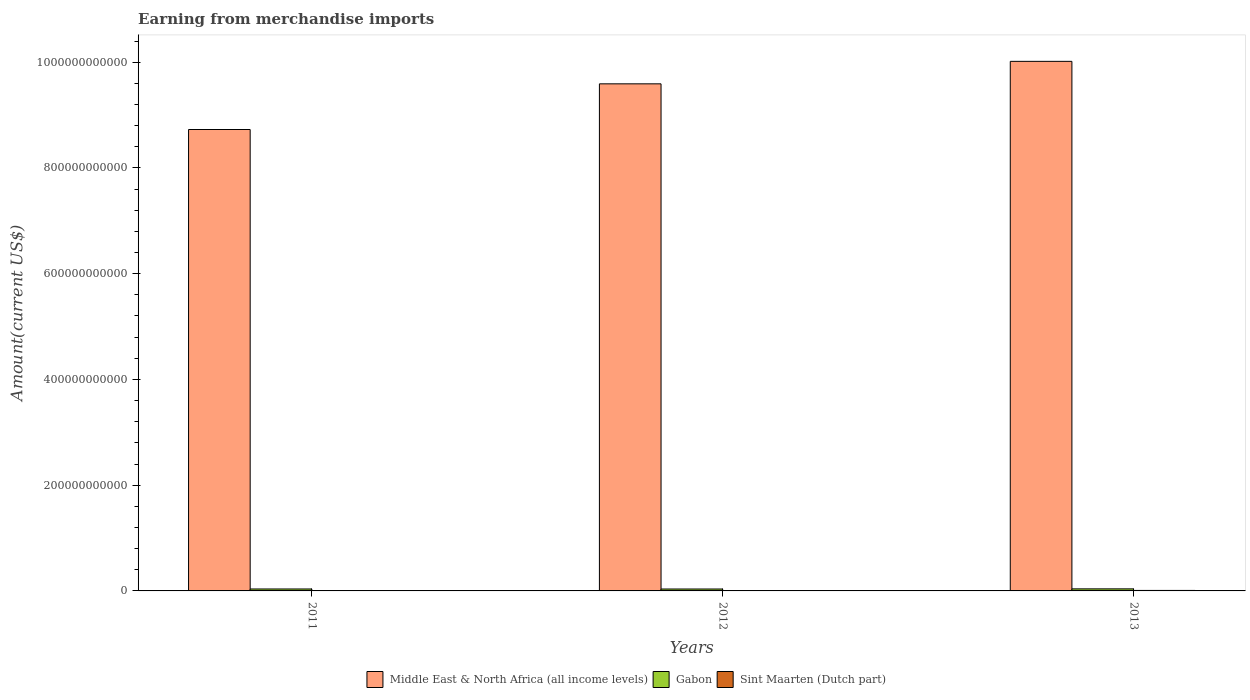How many bars are there on the 1st tick from the left?
Keep it short and to the point. 3. What is the label of the 2nd group of bars from the left?
Keep it short and to the point. 2012. What is the amount earned from merchandise imports in Gabon in 2013?
Your answer should be very brief. 3.88e+09. Across all years, what is the maximum amount earned from merchandise imports in Gabon?
Offer a terse response. 3.88e+09. Across all years, what is the minimum amount earned from merchandise imports in Middle East & North Africa (all income levels)?
Your answer should be very brief. 8.73e+11. In which year was the amount earned from merchandise imports in Middle East & North Africa (all income levels) maximum?
Your answer should be very brief. 2013. In which year was the amount earned from merchandise imports in Sint Maarten (Dutch part) minimum?
Make the answer very short. 2011. What is the total amount earned from merchandise imports in Middle East & North Africa (all income levels) in the graph?
Provide a succinct answer. 2.83e+12. What is the difference between the amount earned from merchandise imports in Gabon in 2012 and that in 2013?
Make the answer very short. -2.51e+08. What is the difference between the amount earned from merchandise imports in Sint Maarten (Dutch part) in 2011 and the amount earned from merchandise imports in Middle East & North Africa (all income levels) in 2013?
Ensure brevity in your answer.  -1.00e+12. What is the average amount earned from merchandise imports in Gabon per year?
Your answer should be very brief. 3.72e+09. In the year 2013, what is the difference between the amount earned from merchandise imports in Sint Maarten (Dutch part) and amount earned from merchandise imports in Gabon?
Your response must be concise. -2.96e+09. In how many years, is the amount earned from merchandise imports in Middle East & North Africa (all income levels) greater than 920000000000 US$?
Ensure brevity in your answer.  2. What is the ratio of the amount earned from merchandise imports in Middle East & North Africa (all income levels) in 2011 to that in 2013?
Offer a very short reply. 0.87. What is the difference between the highest and the second highest amount earned from merchandise imports in Sint Maarten (Dutch part)?
Keep it short and to the point. 1.56e+08. What is the difference between the highest and the lowest amount earned from merchandise imports in Gabon?
Ensure brevity in your answer.  2.51e+08. Is the sum of the amount earned from merchandise imports in Gabon in 2011 and 2013 greater than the maximum amount earned from merchandise imports in Sint Maarten (Dutch part) across all years?
Ensure brevity in your answer.  Yes. What does the 3rd bar from the left in 2011 represents?
Your response must be concise. Sint Maarten (Dutch part). What does the 3rd bar from the right in 2011 represents?
Provide a succinct answer. Middle East & North Africa (all income levels). Are all the bars in the graph horizontal?
Keep it short and to the point. No. How many years are there in the graph?
Give a very brief answer. 3. What is the difference between two consecutive major ticks on the Y-axis?
Offer a terse response. 2.00e+11. Does the graph contain grids?
Ensure brevity in your answer.  No. Where does the legend appear in the graph?
Give a very brief answer. Bottom center. What is the title of the graph?
Provide a short and direct response. Earning from merchandise imports. Does "Upper middle income" appear as one of the legend labels in the graph?
Offer a terse response. No. What is the label or title of the X-axis?
Offer a very short reply. Years. What is the label or title of the Y-axis?
Offer a very short reply. Amount(current US$). What is the Amount(current US$) in Middle East & North Africa (all income levels) in 2011?
Offer a terse response. 8.73e+11. What is the Amount(current US$) of Gabon in 2011?
Your answer should be compact. 3.67e+09. What is the Amount(current US$) in Sint Maarten (Dutch part) in 2011?
Offer a very short reply. 7.34e+08. What is the Amount(current US$) of Middle East & North Africa (all income levels) in 2012?
Provide a short and direct response. 9.59e+11. What is the Amount(current US$) in Gabon in 2012?
Your answer should be compact. 3.63e+09. What is the Amount(current US$) in Sint Maarten (Dutch part) in 2012?
Give a very brief answer. 7.68e+08. What is the Amount(current US$) in Middle East & North Africa (all income levels) in 2013?
Keep it short and to the point. 1.00e+12. What is the Amount(current US$) in Gabon in 2013?
Make the answer very short. 3.88e+09. What is the Amount(current US$) of Sint Maarten (Dutch part) in 2013?
Ensure brevity in your answer.  9.24e+08. Across all years, what is the maximum Amount(current US$) in Middle East & North Africa (all income levels)?
Your answer should be very brief. 1.00e+12. Across all years, what is the maximum Amount(current US$) of Gabon?
Keep it short and to the point. 3.88e+09. Across all years, what is the maximum Amount(current US$) of Sint Maarten (Dutch part)?
Offer a very short reply. 9.24e+08. Across all years, what is the minimum Amount(current US$) of Middle East & North Africa (all income levels)?
Offer a terse response. 8.73e+11. Across all years, what is the minimum Amount(current US$) in Gabon?
Make the answer very short. 3.63e+09. Across all years, what is the minimum Amount(current US$) of Sint Maarten (Dutch part)?
Your answer should be compact. 7.34e+08. What is the total Amount(current US$) in Middle East & North Africa (all income levels) in the graph?
Your answer should be compact. 2.83e+12. What is the total Amount(current US$) of Gabon in the graph?
Offer a very short reply. 1.12e+1. What is the total Amount(current US$) in Sint Maarten (Dutch part) in the graph?
Provide a short and direct response. 2.43e+09. What is the difference between the Amount(current US$) in Middle East & North Africa (all income levels) in 2011 and that in 2012?
Keep it short and to the point. -8.64e+1. What is the difference between the Amount(current US$) in Gabon in 2011 and that in 2012?
Your response must be concise. 3.63e+07. What is the difference between the Amount(current US$) in Sint Maarten (Dutch part) in 2011 and that in 2012?
Keep it short and to the point. -3.43e+07. What is the difference between the Amount(current US$) in Middle East & North Africa (all income levels) in 2011 and that in 2013?
Keep it short and to the point. -1.29e+11. What is the difference between the Amount(current US$) of Gabon in 2011 and that in 2013?
Ensure brevity in your answer.  -2.14e+08. What is the difference between the Amount(current US$) of Sint Maarten (Dutch part) in 2011 and that in 2013?
Your response must be concise. -1.91e+08. What is the difference between the Amount(current US$) of Middle East & North Africa (all income levels) in 2012 and that in 2013?
Keep it short and to the point. -4.25e+1. What is the difference between the Amount(current US$) in Gabon in 2012 and that in 2013?
Your answer should be compact. -2.51e+08. What is the difference between the Amount(current US$) in Sint Maarten (Dutch part) in 2012 and that in 2013?
Ensure brevity in your answer.  -1.56e+08. What is the difference between the Amount(current US$) of Middle East & North Africa (all income levels) in 2011 and the Amount(current US$) of Gabon in 2012?
Provide a succinct answer. 8.69e+11. What is the difference between the Amount(current US$) in Middle East & North Africa (all income levels) in 2011 and the Amount(current US$) in Sint Maarten (Dutch part) in 2012?
Offer a terse response. 8.72e+11. What is the difference between the Amount(current US$) of Gabon in 2011 and the Amount(current US$) of Sint Maarten (Dutch part) in 2012?
Your answer should be compact. 2.90e+09. What is the difference between the Amount(current US$) of Middle East & North Africa (all income levels) in 2011 and the Amount(current US$) of Gabon in 2013?
Offer a very short reply. 8.69e+11. What is the difference between the Amount(current US$) of Middle East & North Africa (all income levels) in 2011 and the Amount(current US$) of Sint Maarten (Dutch part) in 2013?
Ensure brevity in your answer.  8.72e+11. What is the difference between the Amount(current US$) of Gabon in 2011 and the Amount(current US$) of Sint Maarten (Dutch part) in 2013?
Your response must be concise. 2.74e+09. What is the difference between the Amount(current US$) in Middle East & North Africa (all income levels) in 2012 and the Amount(current US$) in Gabon in 2013?
Offer a terse response. 9.55e+11. What is the difference between the Amount(current US$) of Middle East & North Africa (all income levels) in 2012 and the Amount(current US$) of Sint Maarten (Dutch part) in 2013?
Make the answer very short. 9.58e+11. What is the difference between the Amount(current US$) of Gabon in 2012 and the Amount(current US$) of Sint Maarten (Dutch part) in 2013?
Your answer should be compact. 2.70e+09. What is the average Amount(current US$) of Middle East & North Africa (all income levels) per year?
Your answer should be very brief. 9.44e+11. What is the average Amount(current US$) in Gabon per year?
Your answer should be very brief. 3.72e+09. What is the average Amount(current US$) of Sint Maarten (Dutch part) per year?
Ensure brevity in your answer.  8.09e+08. In the year 2011, what is the difference between the Amount(current US$) in Middle East & North Africa (all income levels) and Amount(current US$) in Gabon?
Offer a very short reply. 8.69e+11. In the year 2011, what is the difference between the Amount(current US$) of Middle East & North Africa (all income levels) and Amount(current US$) of Sint Maarten (Dutch part)?
Your response must be concise. 8.72e+11. In the year 2011, what is the difference between the Amount(current US$) of Gabon and Amount(current US$) of Sint Maarten (Dutch part)?
Offer a terse response. 2.93e+09. In the year 2012, what is the difference between the Amount(current US$) in Middle East & North Africa (all income levels) and Amount(current US$) in Gabon?
Ensure brevity in your answer.  9.55e+11. In the year 2012, what is the difference between the Amount(current US$) in Middle East & North Africa (all income levels) and Amount(current US$) in Sint Maarten (Dutch part)?
Give a very brief answer. 9.58e+11. In the year 2012, what is the difference between the Amount(current US$) in Gabon and Amount(current US$) in Sint Maarten (Dutch part)?
Your answer should be compact. 2.86e+09. In the year 2013, what is the difference between the Amount(current US$) in Middle East & North Africa (all income levels) and Amount(current US$) in Gabon?
Offer a very short reply. 9.98e+11. In the year 2013, what is the difference between the Amount(current US$) of Middle East & North Africa (all income levels) and Amount(current US$) of Sint Maarten (Dutch part)?
Give a very brief answer. 1.00e+12. In the year 2013, what is the difference between the Amount(current US$) in Gabon and Amount(current US$) in Sint Maarten (Dutch part)?
Make the answer very short. 2.96e+09. What is the ratio of the Amount(current US$) of Middle East & North Africa (all income levels) in 2011 to that in 2012?
Your answer should be compact. 0.91. What is the ratio of the Amount(current US$) in Sint Maarten (Dutch part) in 2011 to that in 2012?
Your answer should be compact. 0.96. What is the ratio of the Amount(current US$) of Middle East & North Africa (all income levels) in 2011 to that in 2013?
Make the answer very short. 0.87. What is the ratio of the Amount(current US$) of Gabon in 2011 to that in 2013?
Your response must be concise. 0.94. What is the ratio of the Amount(current US$) in Sint Maarten (Dutch part) in 2011 to that in 2013?
Give a very brief answer. 0.79. What is the ratio of the Amount(current US$) of Middle East & North Africa (all income levels) in 2012 to that in 2013?
Your answer should be compact. 0.96. What is the ratio of the Amount(current US$) in Gabon in 2012 to that in 2013?
Keep it short and to the point. 0.94. What is the ratio of the Amount(current US$) in Sint Maarten (Dutch part) in 2012 to that in 2013?
Offer a very short reply. 0.83. What is the difference between the highest and the second highest Amount(current US$) of Middle East & North Africa (all income levels)?
Keep it short and to the point. 4.25e+1. What is the difference between the highest and the second highest Amount(current US$) in Gabon?
Ensure brevity in your answer.  2.14e+08. What is the difference between the highest and the second highest Amount(current US$) in Sint Maarten (Dutch part)?
Make the answer very short. 1.56e+08. What is the difference between the highest and the lowest Amount(current US$) of Middle East & North Africa (all income levels)?
Your answer should be compact. 1.29e+11. What is the difference between the highest and the lowest Amount(current US$) of Gabon?
Provide a short and direct response. 2.51e+08. What is the difference between the highest and the lowest Amount(current US$) in Sint Maarten (Dutch part)?
Your answer should be very brief. 1.91e+08. 